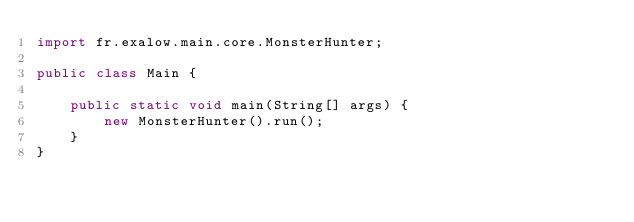Convert code to text. <code><loc_0><loc_0><loc_500><loc_500><_Java_>import fr.exalow.main.core.MonsterHunter;

public class Main {

    public static void main(String[] args) {
        new MonsterHunter().run();
    }
}
</code> 